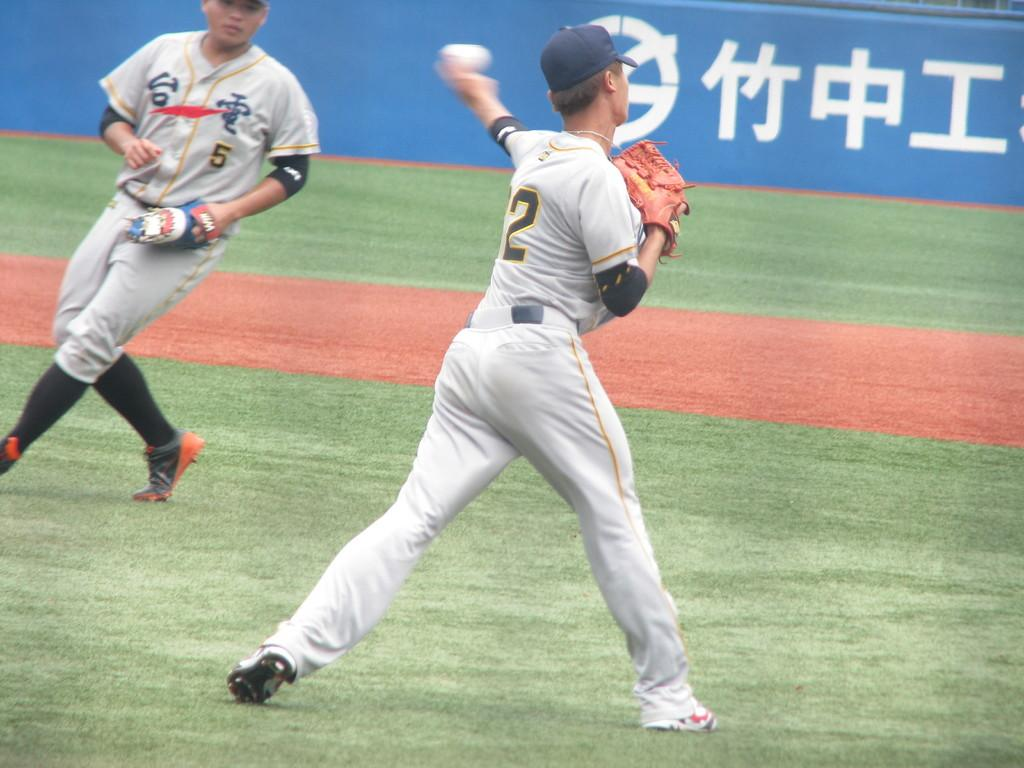<image>
Describe the image concisely. Two baseball players, numbers 5 and 2, one of which is throwing the ball. 